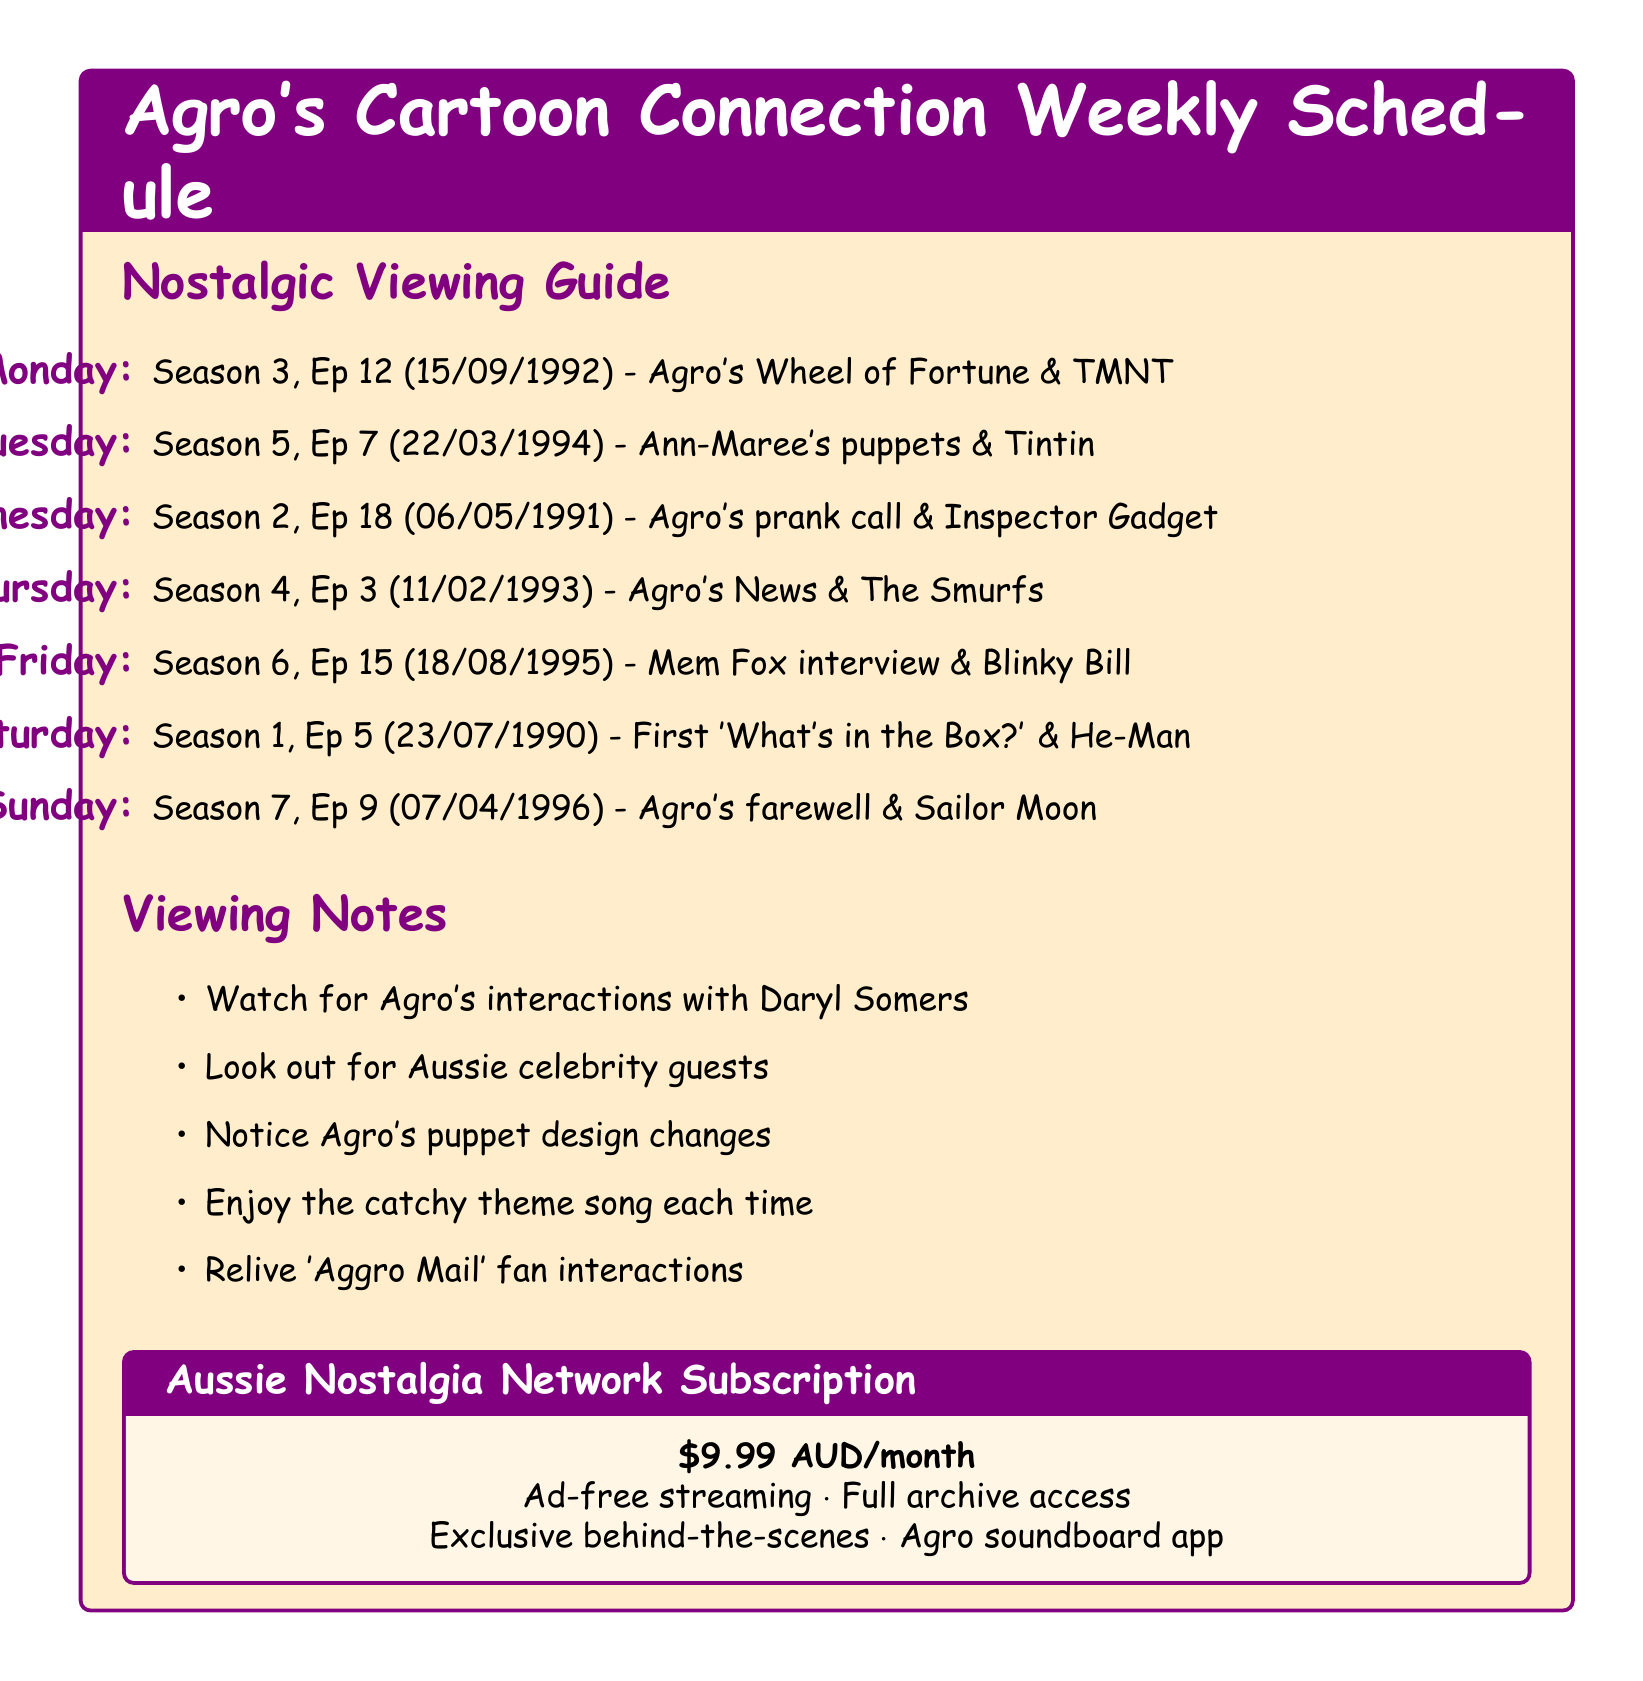What episode airs on Monday? The document specifies the episode that airs on Monday, which is Season 3, Episode 12.
Answer: Season 3, Episode 12 What is the air date for Season 5, Episode 7? The document lists the air date for this episode as March 22, 1994.
Answer: March 22, 1994 Which segment features Agro's prank call? The segment mentioned in the document is "Agro's prank call to a local pizza shop."
Answer: Agro's prank call to a local pizza shop What cartoon is featured on Friday's episode? The document indicates the cartoon featured on Friday is "Blinky Bill."
Answer: Blinky Bill How much is the subscription for the streaming platform? The document states the subscription price for the Aussie Nostalgia Network is $9.99 AUD per month.
Answer: $9.99 AUD per month On which day does Agro's farewell speech air? According to the document, Agro's farewell speech airs on Sunday.
Answer: Sunday Which segment is highlighted for Wednesday's episode? The document emphasizes "Agro's prank call to a local pizza shop" as a favorite segment for Wednesday.
Answer: Agro's prank call to a local pizza shop What is one of the additional notes related to the viewing experience? The document includes various notes; one is "Look out for guest appearances by other Australian celebrities."
Answer: Look out for guest appearances by other Australian celebrities What cartoon is aired with Agro's first appearance of the 'What's in the Box?' game? The document mentions "The New Adventures of He-Man" aired with that segment on Saturday.
Answer: The New Adventures of He-Man 